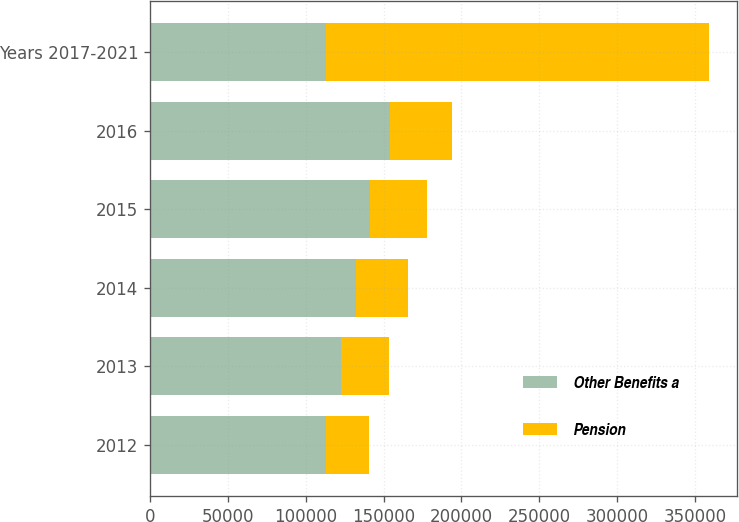Convert chart to OTSL. <chart><loc_0><loc_0><loc_500><loc_500><stacked_bar_chart><ecel><fcel>2012<fcel>2013<fcel>2014<fcel>2015<fcel>2016<fcel>Years 2017-2021<nl><fcel>Other Benefits a<fcel>113075<fcel>122750<fcel>132302<fcel>141516<fcel>154379<fcel>113075<nl><fcel>Pension<fcel>27610<fcel>30562<fcel>33451<fcel>36489<fcel>39525<fcel>246091<nl></chart> 